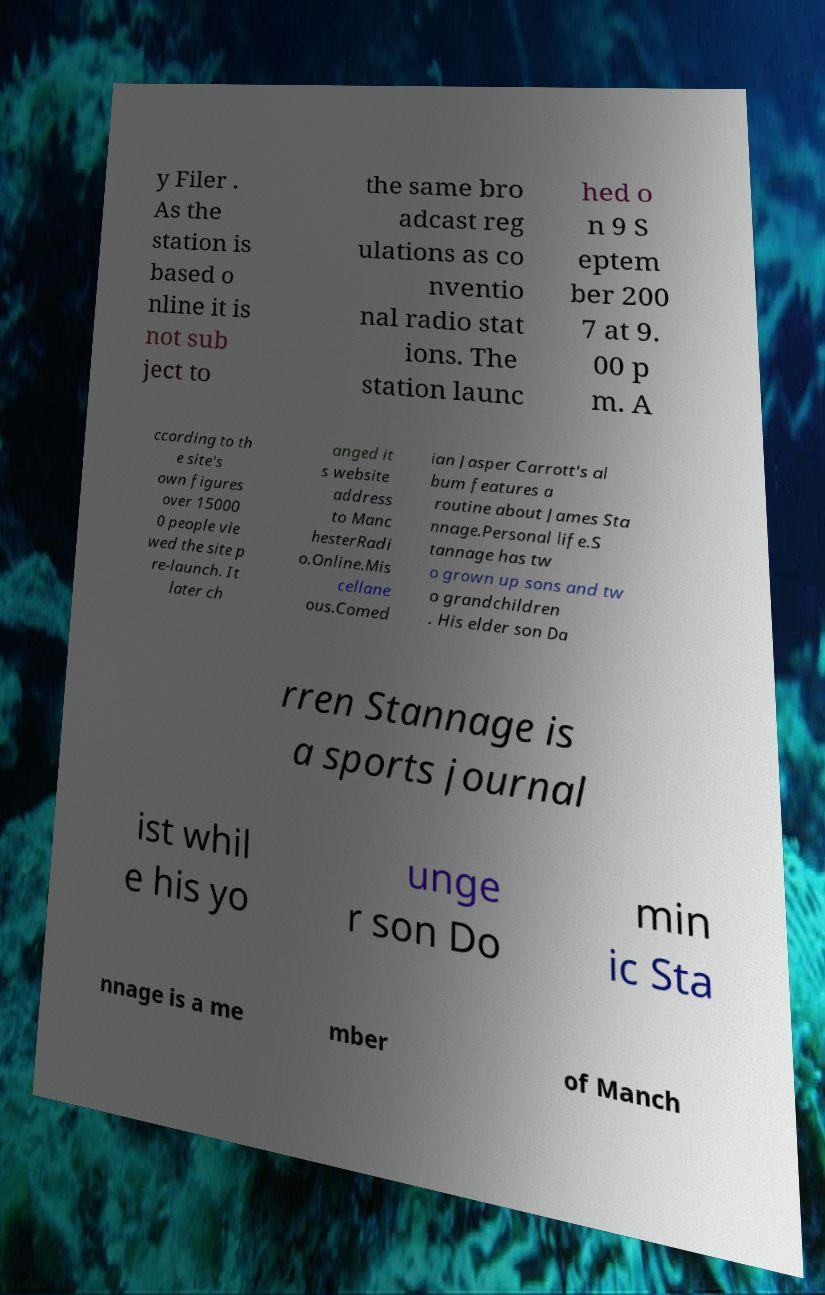What messages or text are displayed in this image? I need them in a readable, typed format. y Filer . As the station is based o nline it is not sub ject to the same bro adcast reg ulations as co nventio nal radio stat ions. The station launc hed o n 9 S eptem ber 200 7 at 9. 00 p m. A ccording to th e site's own figures over 15000 0 people vie wed the site p re-launch. It later ch anged it s website address to Manc hesterRadi o.Online.Mis cellane ous.Comed ian Jasper Carrott's al bum features a routine about James Sta nnage.Personal life.S tannage has tw o grown up sons and tw o grandchildren . His elder son Da rren Stannage is a sports journal ist whil e his yo unge r son Do min ic Sta nnage is a me mber of Manch 